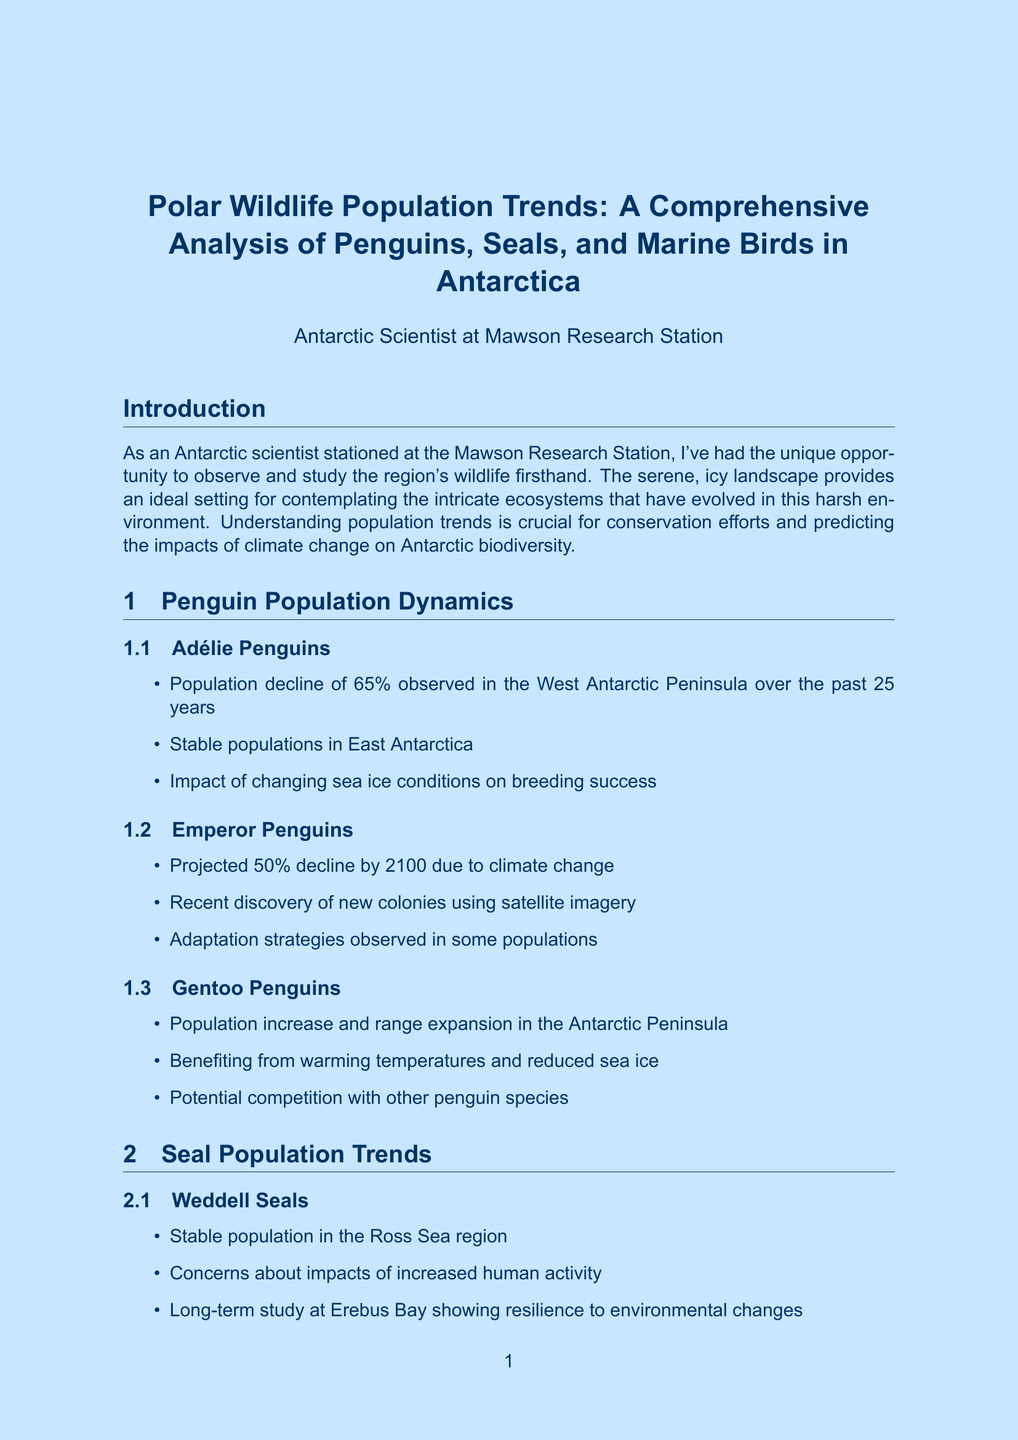What is the population decline percentage of Adélie Penguins observed in the West Antarctic Peninsula? The document states that there is a population decline of 65% observed in the West Antarctic Peninsula over the past 25 years.
Answer: 65% What is the projected decline percentage of Emperor Penguins by 2100? According to the report, Emperor Penguins are projected to decline by 50% due to climate change by 2100.
Answer: 50% How many individuals are estimated to be in the Crabeater Seal population? The document provides population estimates for Crabeater Seals ranging from 5 to 15 million individuals.
Answer: 5 to 15 million What adaptation do Snow Petrels have for nesting? The report mentions that Snow Petrels have a unique adaptation to nesting in rock crevices on nunataks.
Answer: Rock crevices on nunataks Which seal species is referred to as a potential indicator species for ecosystem health? Leopard Seals are mentioned as a potential indicator species for ecosystem health in the document.
Answer: Leopard Seals What research method involves the analysis of satellite imagery? The document lists satellite imagery as one of the research methods used for analyzing population estimates and habitat mapping.
Answer: Satellite imagery What is a key finding regarding species responses to climate change? The document highlights that there are varying responses to climate change among different species as a key finding.
Answer: Varying responses to climate change What is the significance of understanding population trends in polar wildlife? The report emphasizes that understanding population trends is crucial for conservation efforts and predicting the impacts of climate change on Antarctic biodiversity.
Answer: Conservation efforts What personal reflection does the author express about Antarctic wildlife? The author reflects on the resilience and adaptability of Antarctic wildlife while sitting in the Mawson Station library.
Answer: Resilience and adaptability 